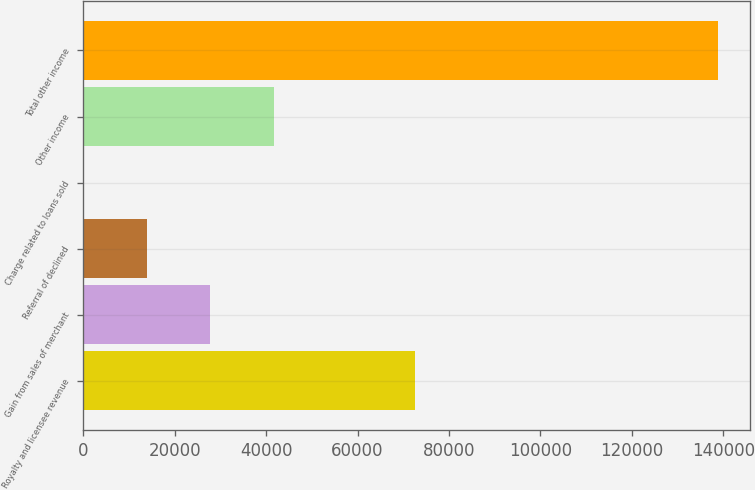Convert chart. <chart><loc_0><loc_0><loc_500><loc_500><bar_chart><fcel>Royalty and licensee revenue<fcel>Gain from sales of merchant<fcel>Referral of declined<fcel>Charge related to loans sold<fcel>Other income<fcel>Total other income<nl><fcel>72636<fcel>27762.3<fcel>13882.4<fcel>2.39<fcel>41642.3<fcel>138802<nl></chart> 